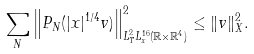<formula> <loc_0><loc_0><loc_500><loc_500>\sum _ { N } \left \| P _ { N } ( | x | ^ { 1 / 4 } v ) \right \| _ { L _ { T } ^ { 2 } L _ { x } ^ { 1 6 } ( \mathbb { R } \times \mathbb { R } ^ { 4 } ) } ^ { 2 } \leq \| v \| _ { X } ^ { 2 } .</formula> 